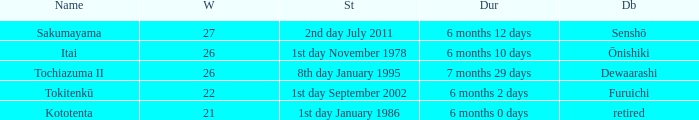Which duration was defeated by retired? 6 months 0 days. 